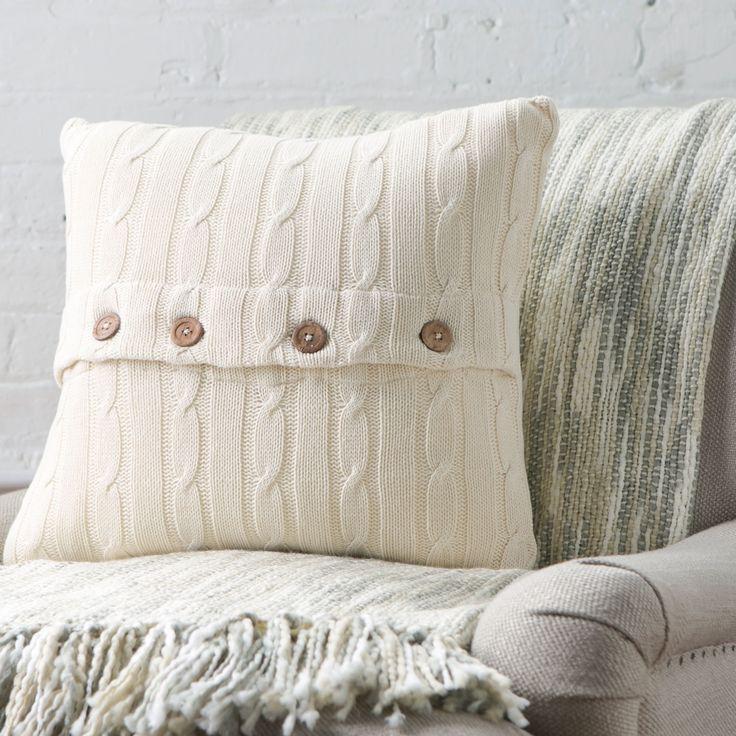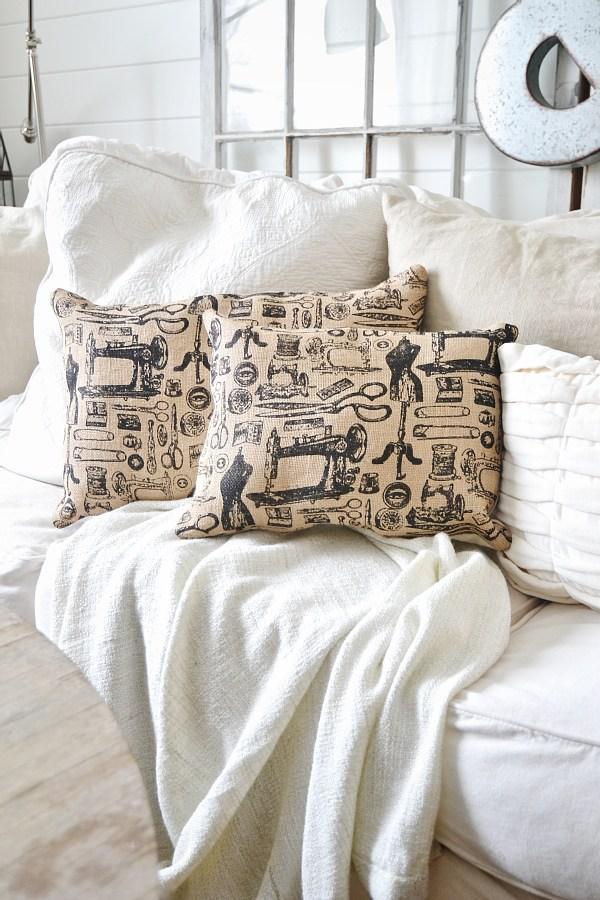The first image is the image on the left, the second image is the image on the right. For the images displayed, is the sentence "One image includes a square pale pillow with a horizontal row of at least three buttons, and the other image features multiple pillows on a white couch, including pillows with all-over picture prints." factually correct? Answer yes or no. Yes. The first image is the image on the left, the second image is the image on the right. Considering the images on both sides, is "In at least one image there is a single knitted pillow with a afghan on top of a sofa chair." valid? Answer yes or no. Yes. 